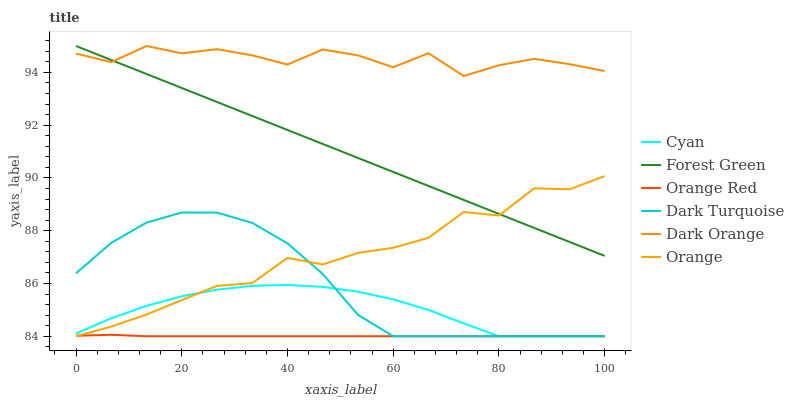Does Orange Red have the minimum area under the curve?
Answer yes or no. Yes. Does Dark Orange have the maximum area under the curve?
Answer yes or no. Yes. Does Dark Turquoise have the minimum area under the curve?
Answer yes or no. No. Does Dark Turquoise have the maximum area under the curve?
Answer yes or no. No. Is Forest Green the smoothest?
Answer yes or no. Yes. Is Dark Orange the roughest?
Answer yes or no. Yes. Is Dark Turquoise the smoothest?
Answer yes or no. No. Is Dark Turquoise the roughest?
Answer yes or no. No. Does Forest Green have the lowest value?
Answer yes or no. No. Does Dark Turquoise have the highest value?
Answer yes or no. No. Is Orange Red less than Dark Orange?
Answer yes or no. Yes. Is Dark Orange greater than Orange?
Answer yes or no. Yes. Does Orange Red intersect Dark Orange?
Answer yes or no. No. 